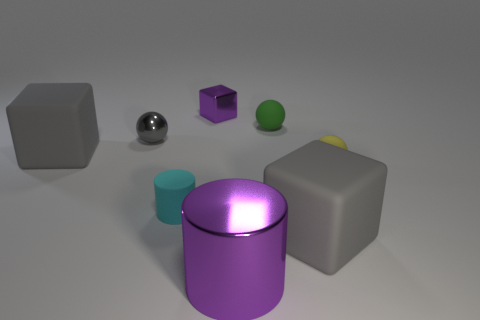Add 2 small cylinders. How many objects exist? 10 Subtract all cylinders. How many objects are left? 6 Add 5 rubber balls. How many rubber balls exist? 7 Subtract 0 brown balls. How many objects are left? 8 Subtract all tiny things. Subtract all green matte blocks. How many objects are left? 3 Add 1 gray metallic things. How many gray metallic things are left? 2 